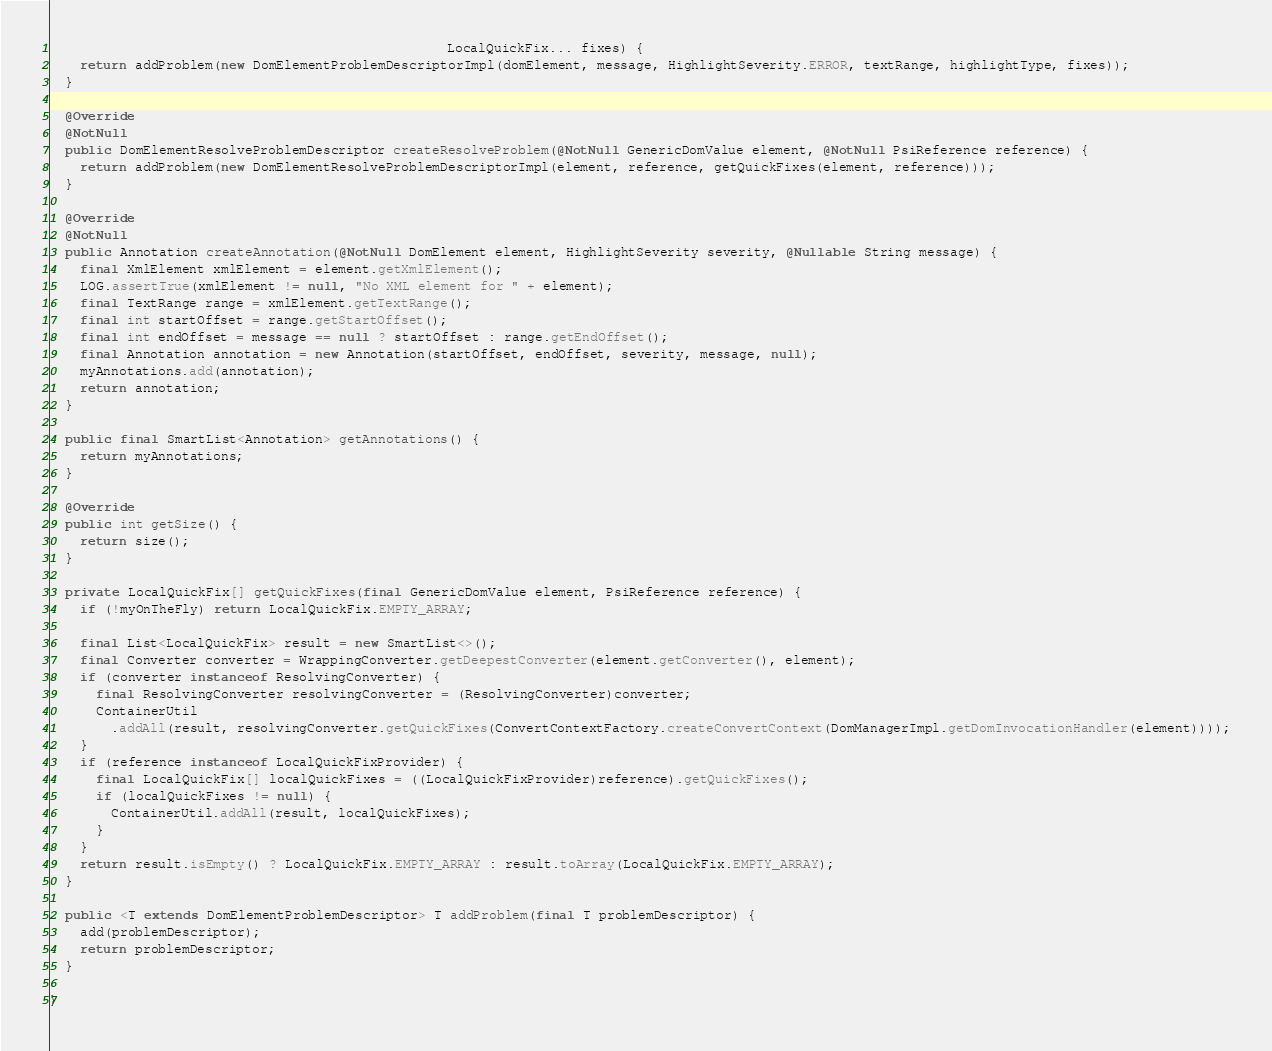<code> <loc_0><loc_0><loc_500><loc_500><_Java_>                                                   LocalQuickFix... fixes) {
    return addProblem(new DomElementProblemDescriptorImpl(domElement, message, HighlightSeverity.ERROR, textRange, highlightType, fixes));
  }

  @Override
  @NotNull
  public DomElementResolveProblemDescriptor createResolveProblem(@NotNull GenericDomValue element, @NotNull PsiReference reference) {
    return addProblem(new DomElementResolveProblemDescriptorImpl(element, reference, getQuickFixes(element, reference)));
  }

  @Override
  @NotNull
  public Annotation createAnnotation(@NotNull DomElement element, HighlightSeverity severity, @Nullable String message) {
    final XmlElement xmlElement = element.getXmlElement();
    LOG.assertTrue(xmlElement != null, "No XML element for " + element);
    final TextRange range = xmlElement.getTextRange();
    final int startOffset = range.getStartOffset();
    final int endOffset = message == null ? startOffset : range.getEndOffset();
    final Annotation annotation = new Annotation(startOffset, endOffset, severity, message, null);
    myAnnotations.add(annotation);
    return annotation;
  }

  public final SmartList<Annotation> getAnnotations() {
    return myAnnotations;
  }

  @Override
  public int getSize() {
    return size();
  }

  private LocalQuickFix[] getQuickFixes(final GenericDomValue element, PsiReference reference) {
    if (!myOnTheFly) return LocalQuickFix.EMPTY_ARRAY;

    final List<LocalQuickFix> result = new SmartList<>();
    final Converter converter = WrappingConverter.getDeepestConverter(element.getConverter(), element);
    if (converter instanceof ResolvingConverter) {
      final ResolvingConverter resolvingConverter = (ResolvingConverter)converter;
      ContainerUtil
        .addAll(result, resolvingConverter.getQuickFixes(ConvertContextFactory.createConvertContext(DomManagerImpl.getDomInvocationHandler(element))));
    }
    if (reference instanceof LocalQuickFixProvider) {
      final LocalQuickFix[] localQuickFixes = ((LocalQuickFixProvider)reference).getQuickFixes();
      if (localQuickFixes != null) {
        ContainerUtil.addAll(result, localQuickFixes);
      }
    }
    return result.isEmpty() ? LocalQuickFix.EMPTY_ARRAY : result.toArray(LocalQuickFix.EMPTY_ARRAY);
  }

  public <T extends DomElementProblemDescriptor> T addProblem(final T problemDescriptor) {
    add(problemDescriptor);
    return problemDescriptor;
  }

}
</code> 